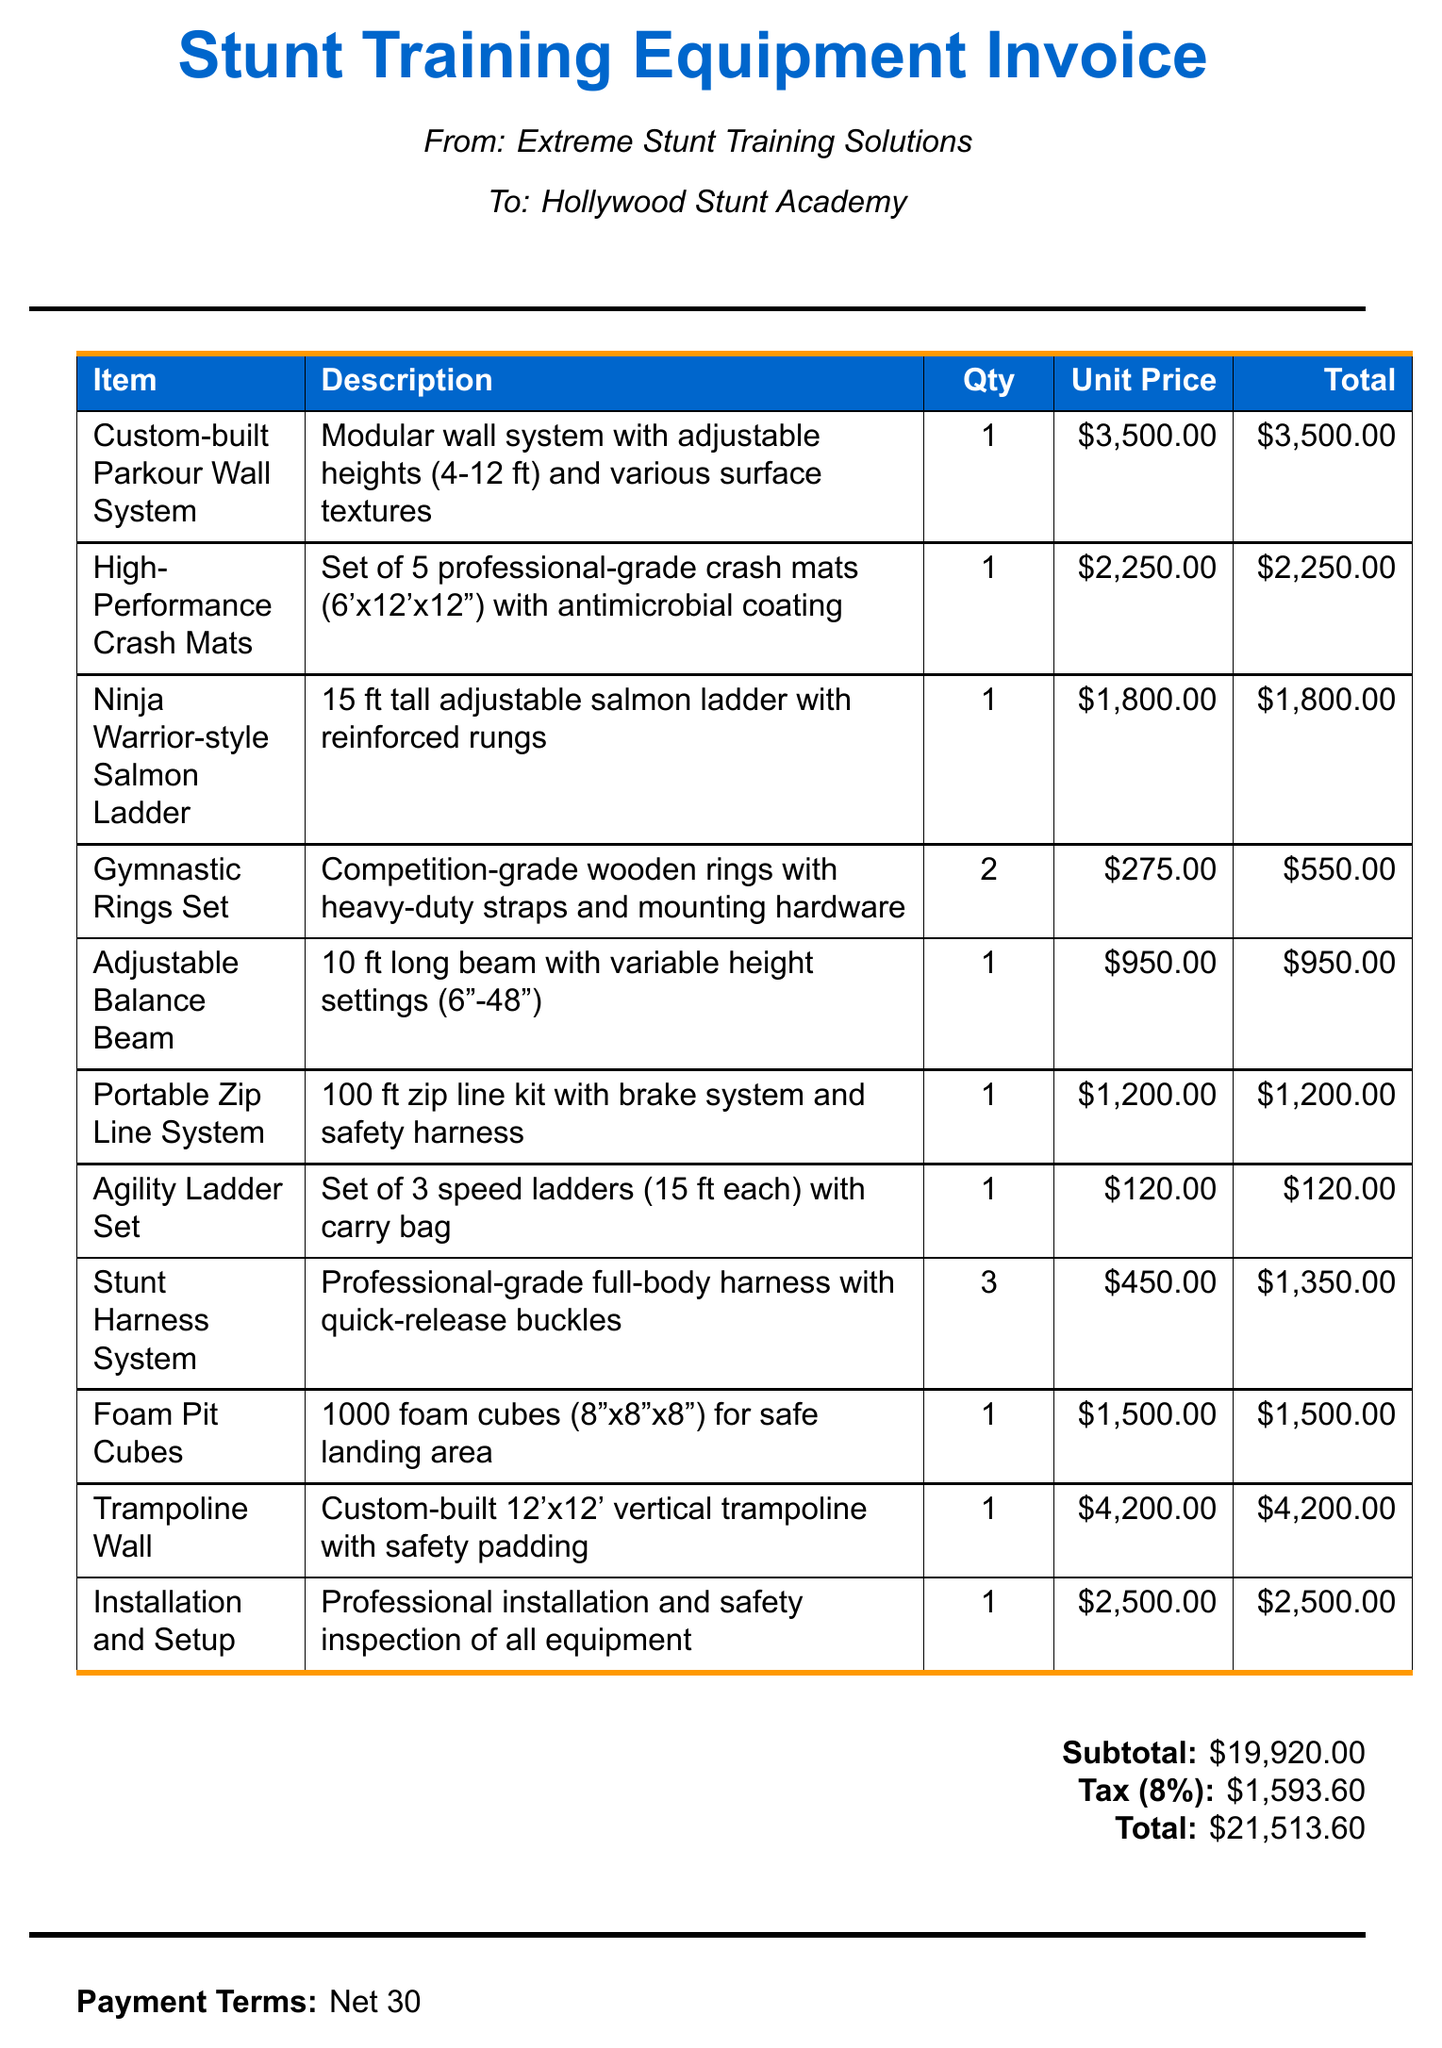What is the item with the highest total cost? The item with the highest total cost can be identified by comparing the total amounts for each line; the "Trampoline Wall" costs $4200.00, which is the highest.
Answer: Trampoline Wall How many Gymnastic Rings Sets were purchased? The quantity for the Gymnastic Rings Set item is indicated clearly in the document; there are 2 purchased.
Answer: 2 What is the subtotal amount before tax? The subtotal is stated in the document as the sum of all invoice items before any taxes are added; it is $19920.00.
Answer: $19920.00 What percentage is the tax rate? The tax rate can be directly found in the document as stated, which is 8%.
Answer: 8% What is the payment term specified in the invoice? The document includes the payment terms statement; it says "Net 30".
Answer: Net 30 What types of items are included in the invoice? The invoice outlines various obstacle course equipment and training gear, such as a "Custom-built Parkour Wall System" and "Stunt Harness System".
Answer: Obstacle course equipment How many Stunt Harness Systems are listed in the invoice? The quantity for the Stunt Harness System is provided in the invoice; there are 3 listed.
Answer: 3 What is the total amount including tax? The total amount includes the subtotal and tax, which is explicitly stated in the document as $21513.60.
Answer: $21513.60 What is recommended regarding equipment maintenance? There is a note regarding equipment maintenance found in the document; it states that "Regular maintenance and safety checks recommended".
Answer: Regular maintenance and safety checks recommended What is the unit price of the Adjustable Balance Beam? The unit price can be identified in the invoice section for the Adjustable Balance Beam, which is specifically listed as $950.00.
Answer: $950.00 